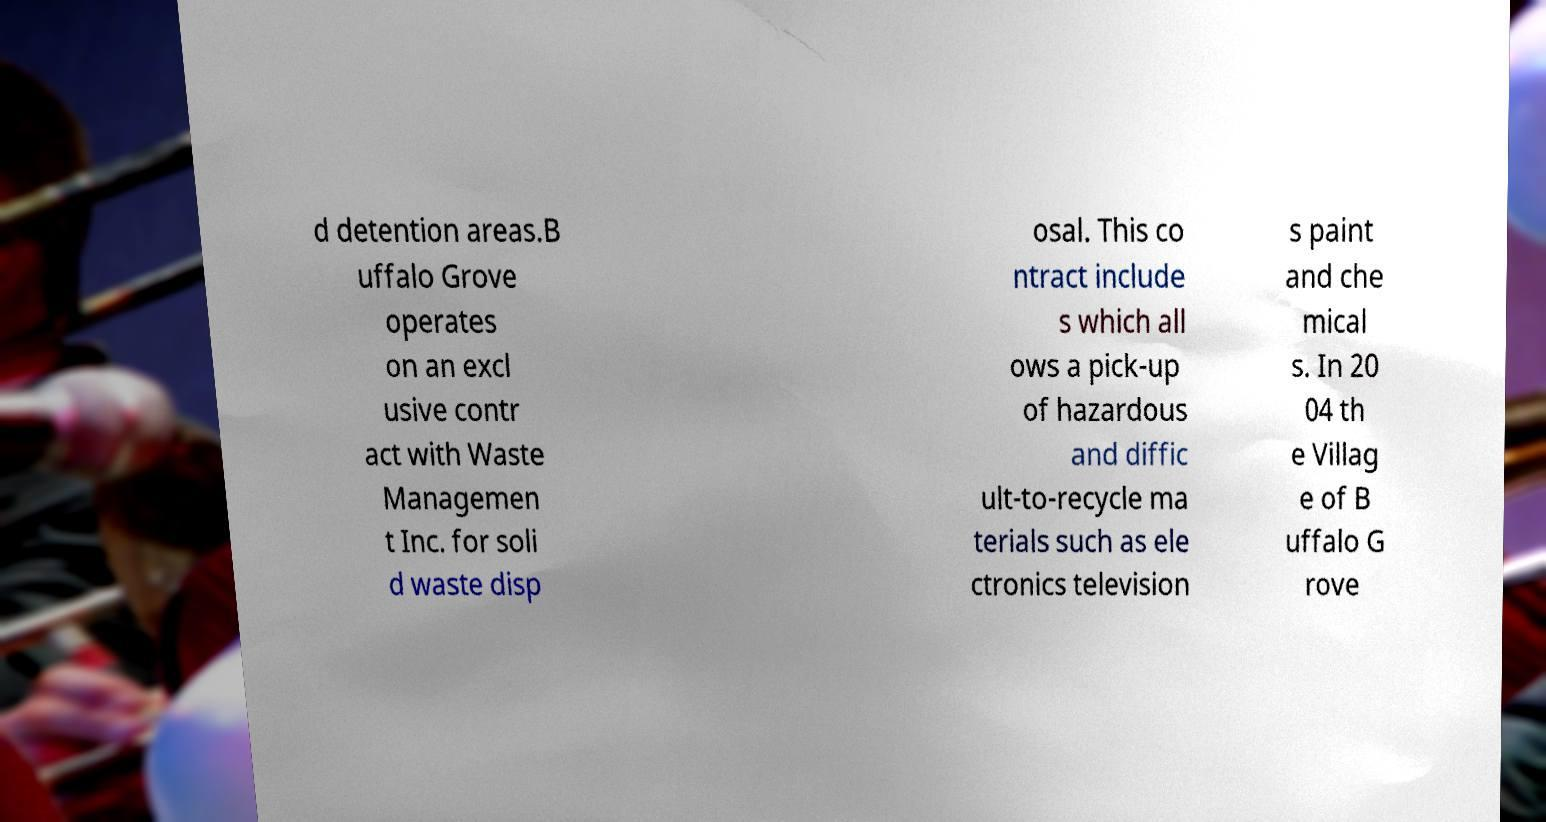Please read and relay the text visible in this image. What does it say? d detention areas.B uffalo Grove operates on an excl usive contr act with Waste Managemen t Inc. for soli d waste disp osal. This co ntract include s which all ows a pick-up of hazardous and diffic ult-to-recycle ma terials such as ele ctronics television s paint and che mical s. In 20 04 th e Villag e of B uffalo G rove 